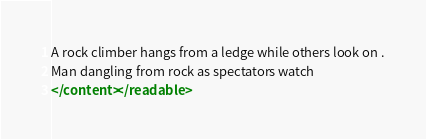<code> <loc_0><loc_0><loc_500><loc_500><_XML_>A rock climber hangs from a ledge while others look on .
Man dangling from rock as spectators watch
</content></readable></code> 